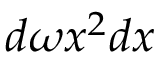<formula> <loc_0><loc_0><loc_500><loc_500>d \omega x ^ { 2 } d x</formula> 